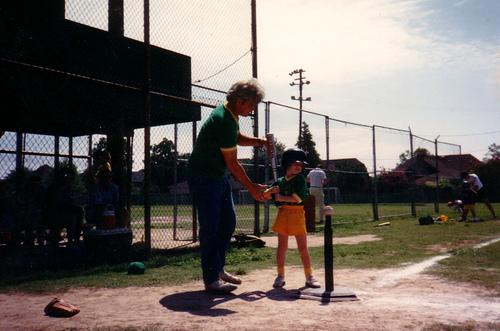Can you describe the clothing item the man helping the batter is wearing? The man helping the batter is wearing a green and yellow ringer shirt. Based on objects in the image, what kind of sentiment does it evoke? The image evokes a cheerful and positive sentiment, depicting a child engaging in sports, accompanied by an adult. Determine the color of the batter's helmet and describe the object it is related to. The batter's helmet is of unspecified color, and it is related to the child standing beside the tee. What is the main activity taking place in this image involving multiple people? The main activity is a child playing baseball, standing beside the tee, being assisted by an adult. In the image, find the object a child is standing next to with its dimensions. The child is standing beside a tee with dimensions of 43x43 (Width and Height). Identify the number of trees in the image and the color of the shorts the batter is wearing. There are 10 trees in the image, and the batter is wearing yellow shorts. Considering the objects' positions and sizes, do you think the image composition is well-balanced? Yes, the image composition seems well-balanced, with objects distributed evenly throughout the scene. How many players are in the dugout, and what condition is present on the field surface? The number of players in the dugout is unspecified, and there are shadows on the dirt surface of the field. Analyze the image and enumerate any unusual relationships or interactions observed between objects. No unusual relationships or interactions observed between objects in the image. Examine the image for any other objects that may be related to the baseball game besides people and the tee. Other objects related to the game include a ball on the tee and the batter's yellow shorts. Describe the scene involving the child and the man helping the batter. The man is assisting the child in their batting stance, as the child prepares to hit a ball on a tee while wearing a helmet and yellow shorts List the objects found in the foreground of the picture. Child, tee with ball, man helping the batter, helmet List the details illustrated in the image related to the baseball scene. Child, tee with a ball on it, man helping the batter, players in the dugout, helmet, yellow shorts, green and yellow shirt Does the batter have any accessories on their head? Yes, the batter is wearing a helmet What is unique about the helmet the batter is wearing in the image? Nothing, it's a standard helmet What position(s) can be seen in the picture regarding the batter? Standing beside the tee, preparing to hit a ball Are there any text and numbers displayed in the image? No Give an assessment of the diagram. The diagram is an annotated image of a child playing baseball with several objects marked, including trees, players, and equipment Identify the most prominent activity happening in the scene. A child preparing to hit a ball on a tee What is the emotional atmosphere in the picture? A) Joyful B) Tense C) Neutral D) Sad A) Joyful What are the coordinates of the ball on the tee? This type of instruction is not feasible as it contains numeric information. Do the shadows on the dirt appear to be long or short? Long What is the main subject in the picture besides the trees? Child standing beside a tee Is there a child wearing a green and yellow ringer shirt at X:260 Y:129? The child is actually standing beside the tee and wearing no mentioned shirt. The green and yellow ringer shirt is at X:176 Y:102. Can you see the tree with a width of 75 and a height of 75 at X:100 Y:138? There is no tree in the image with a width of 75 and a height of 75. The actual tree at X:100 Y:138 has a width of 46 and a height of 46. Which of these expressions can be seen in the image? A) Smiling B) Angry C) Neutral D) Surprised C) Neutral What is common between the objects found in the background of the picture? They are all trees What color are the shorts worn by the batter in the image? Yellow Are there more trees in the background or players in the dugout? More trees in the background Do you see any shadows on the grass located at X:156 Y:282? The image mentions shadows on the dirt at X:156 Y:282, not on the grass. The grass on the field can be found at X:159 Y:209. What can be inferred about the location of the scene? The scene likely takes place on a baseball field in a park with several trees in the background Is there a player wearing purple shorts instead of yellow shorts at X:267 Y:200? The image mentions a player wearing yellow shorts at X:267 Y:200, but there is no mention of anyone wearing purple shorts. What is the most dominant color on the field in the image? Green Describe the shirt worn by the man helping the batter. Green and yellow ringer shirt Can you locate the helmet with a width of 50 and a height of 50 at X:278 Y:142? There is no helmet in the image with a width of 50 and a height of 50. The actual helmet at X:278 Y:142 has a width of 28 and a height of 28. Can you find the tee with a ball on it located at X:400 Y:300? There is no tee with a ball on it at X:400 Y:300. The actual tee with a ball on it is located at X:315 Y:201. 